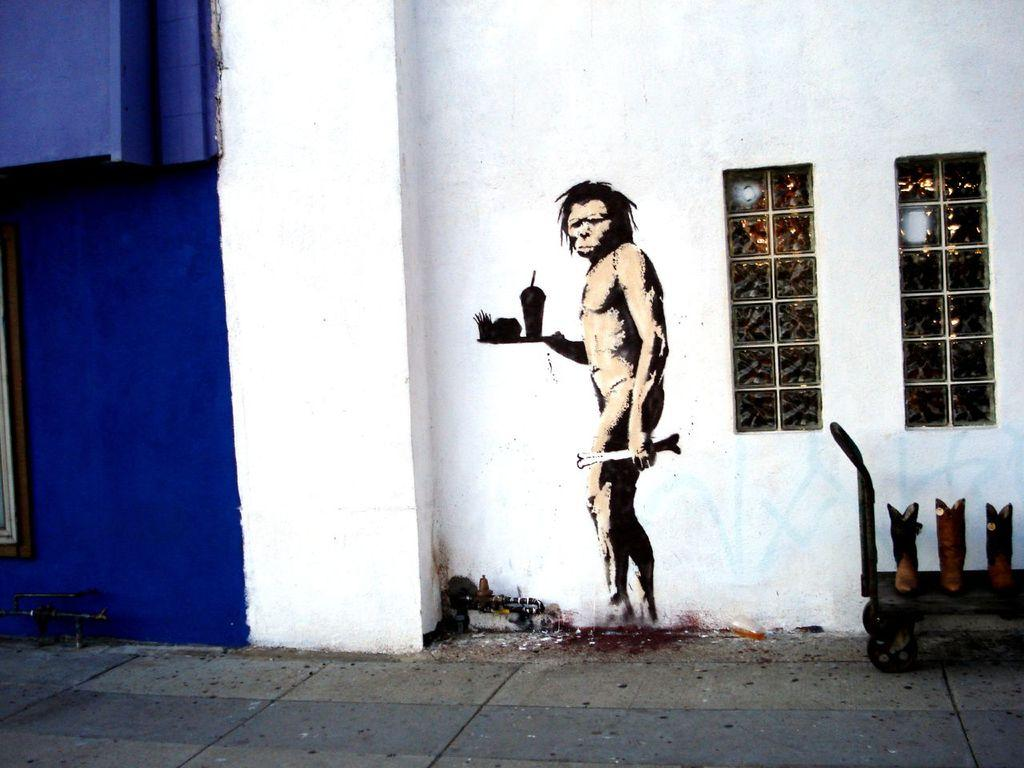What object is on the ground in the image? There is a cart on the ground in the image. What can be seen through the windows in the image? The presence of windows suggests that there is a view of the outside or another room, but the specific view cannot be determined from the provided facts. What type of artwork is on the wall in the image? There is a painting of a man on the wall in the image. What type of nerve is being stimulated by the hook in the image? There is no hook present in the image, so it is not possible to determine which nerve might be stimulated. 